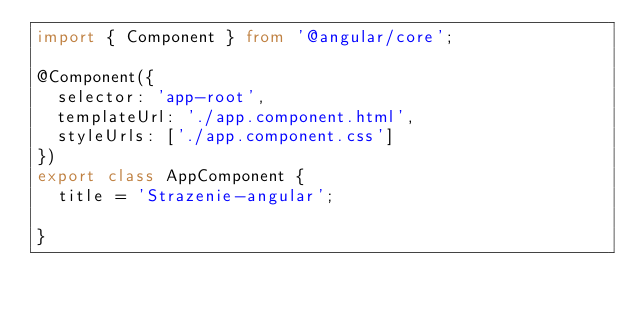Convert code to text. <code><loc_0><loc_0><loc_500><loc_500><_TypeScript_>import { Component } from '@angular/core';

@Component({
  selector: 'app-root',
  templateUrl: './app.component.html',
  styleUrls: ['./app.component.css']
})
export class AppComponent {
  title = 'Strazenie-angular';
  
}
</code> 